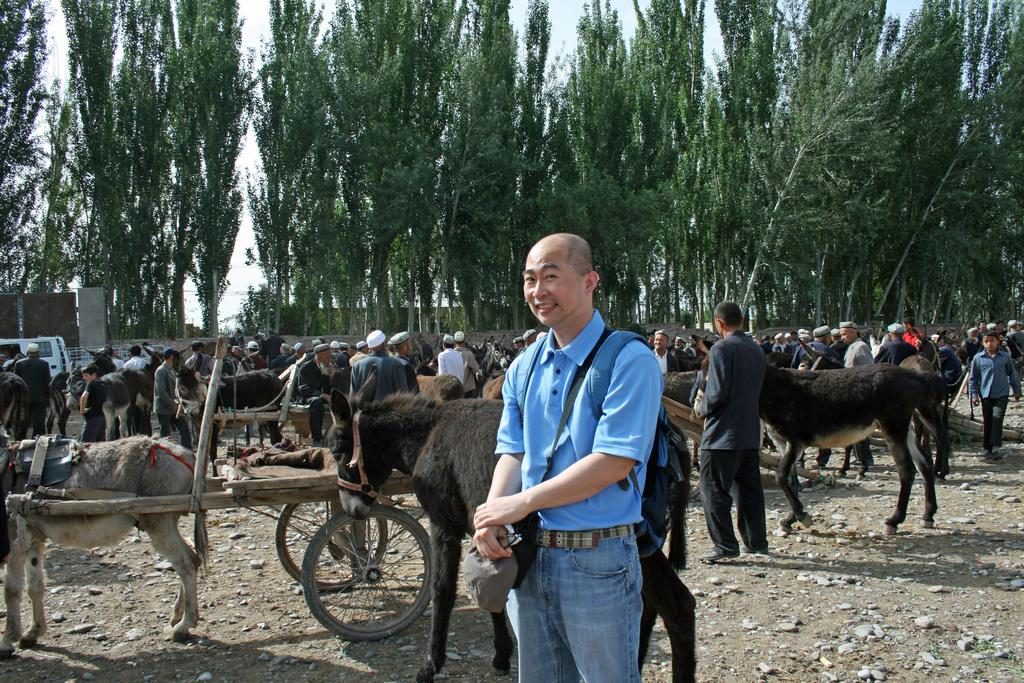What is the main subject in the image? There is a person standing in the image. What can be seen in the background of the image? There are donkey carts, people, a wall, and trees in the background of the image. How many women are wearing a ring on their left hand in the image? There is no mention of women or rings in the image, so this question cannot be answered. 